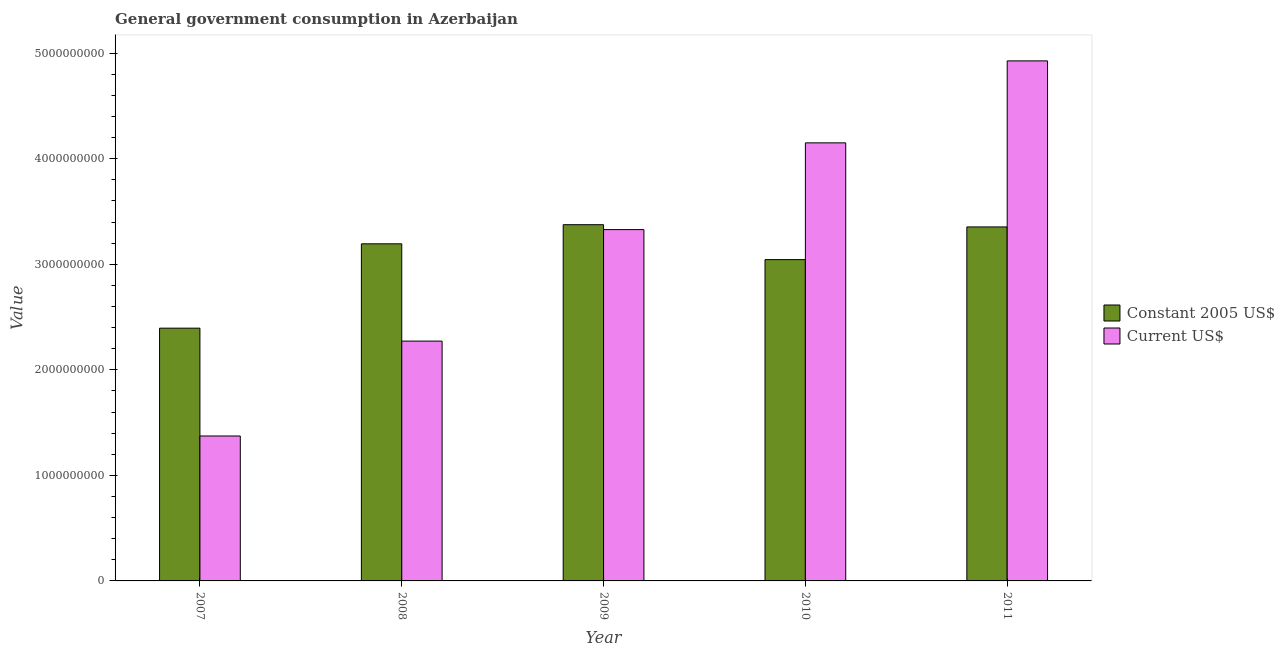How many different coloured bars are there?
Offer a very short reply. 2. Are the number of bars per tick equal to the number of legend labels?
Give a very brief answer. Yes. How many bars are there on the 1st tick from the right?
Offer a very short reply. 2. What is the label of the 1st group of bars from the left?
Your answer should be very brief. 2007. What is the value consumed in constant 2005 us$ in 2011?
Give a very brief answer. 3.35e+09. Across all years, what is the maximum value consumed in current us$?
Offer a very short reply. 4.93e+09. Across all years, what is the minimum value consumed in constant 2005 us$?
Offer a terse response. 2.39e+09. What is the total value consumed in constant 2005 us$ in the graph?
Provide a short and direct response. 1.54e+1. What is the difference between the value consumed in constant 2005 us$ in 2008 and that in 2009?
Your answer should be very brief. -1.81e+08. What is the difference between the value consumed in current us$ in 2008 and the value consumed in constant 2005 us$ in 2010?
Your answer should be compact. -1.88e+09. What is the average value consumed in current us$ per year?
Offer a very short reply. 3.21e+09. What is the ratio of the value consumed in current us$ in 2010 to that in 2011?
Offer a terse response. 0.84. Is the difference between the value consumed in constant 2005 us$ in 2010 and 2011 greater than the difference between the value consumed in current us$ in 2010 and 2011?
Provide a succinct answer. No. What is the difference between the highest and the second highest value consumed in constant 2005 us$?
Your answer should be very brief. 2.11e+07. What is the difference between the highest and the lowest value consumed in current us$?
Ensure brevity in your answer.  3.55e+09. What does the 2nd bar from the left in 2011 represents?
Your answer should be compact. Current US$. What does the 1st bar from the right in 2009 represents?
Offer a terse response. Current US$. How many years are there in the graph?
Your answer should be very brief. 5. What is the difference between two consecutive major ticks on the Y-axis?
Give a very brief answer. 1.00e+09. Does the graph contain any zero values?
Keep it short and to the point. No. Where does the legend appear in the graph?
Provide a succinct answer. Center right. What is the title of the graph?
Make the answer very short. General government consumption in Azerbaijan. What is the label or title of the X-axis?
Give a very brief answer. Year. What is the label or title of the Y-axis?
Make the answer very short. Value. What is the Value in Constant 2005 US$ in 2007?
Keep it short and to the point. 2.39e+09. What is the Value in Current US$ in 2007?
Offer a very short reply. 1.37e+09. What is the Value in Constant 2005 US$ in 2008?
Offer a very short reply. 3.19e+09. What is the Value in Current US$ in 2008?
Your answer should be compact. 2.27e+09. What is the Value in Constant 2005 US$ in 2009?
Your answer should be compact. 3.37e+09. What is the Value of Current US$ in 2009?
Your response must be concise. 3.33e+09. What is the Value in Constant 2005 US$ in 2010?
Offer a terse response. 3.04e+09. What is the Value in Current US$ in 2010?
Provide a short and direct response. 4.15e+09. What is the Value of Constant 2005 US$ in 2011?
Your answer should be compact. 3.35e+09. What is the Value of Current US$ in 2011?
Ensure brevity in your answer.  4.93e+09. Across all years, what is the maximum Value in Constant 2005 US$?
Give a very brief answer. 3.37e+09. Across all years, what is the maximum Value of Current US$?
Ensure brevity in your answer.  4.93e+09. Across all years, what is the minimum Value of Constant 2005 US$?
Your answer should be very brief. 2.39e+09. Across all years, what is the minimum Value in Current US$?
Ensure brevity in your answer.  1.37e+09. What is the total Value of Constant 2005 US$ in the graph?
Keep it short and to the point. 1.54e+1. What is the total Value of Current US$ in the graph?
Provide a short and direct response. 1.61e+1. What is the difference between the Value of Constant 2005 US$ in 2007 and that in 2008?
Offer a terse response. -7.99e+08. What is the difference between the Value of Current US$ in 2007 and that in 2008?
Provide a short and direct response. -8.99e+08. What is the difference between the Value in Constant 2005 US$ in 2007 and that in 2009?
Your answer should be compact. -9.80e+08. What is the difference between the Value in Current US$ in 2007 and that in 2009?
Offer a terse response. -1.96e+09. What is the difference between the Value in Constant 2005 US$ in 2007 and that in 2010?
Provide a short and direct response. -6.49e+08. What is the difference between the Value of Current US$ in 2007 and that in 2010?
Your answer should be compact. -2.78e+09. What is the difference between the Value in Constant 2005 US$ in 2007 and that in 2011?
Provide a short and direct response. -9.59e+08. What is the difference between the Value in Current US$ in 2007 and that in 2011?
Offer a very short reply. -3.55e+09. What is the difference between the Value of Constant 2005 US$ in 2008 and that in 2009?
Make the answer very short. -1.81e+08. What is the difference between the Value of Current US$ in 2008 and that in 2009?
Your answer should be very brief. -1.06e+09. What is the difference between the Value of Constant 2005 US$ in 2008 and that in 2010?
Provide a short and direct response. 1.50e+08. What is the difference between the Value in Current US$ in 2008 and that in 2010?
Keep it short and to the point. -1.88e+09. What is the difference between the Value of Constant 2005 US$ in 2008 and that in 2011?
Make the answer very short. -1.60e+08. What is the difference between the Value of Current US$ in 2008 and that in 2011?
Provide a short and direct response. -2.65e+09. What is the difference between the Value of Constant 2005 US$ in 2009 and that in 2010?
Offer a terse response. 3.31e+08. What is the difference between the Value in Current US$ in 2009 and that in 2010?
Offer a terse response. -8.22e+08. What is the difference between the Value of Constant 2005 US$ in 2009 and that in 2011?
Provide a succinct answer. 2.11e+07. What is the difference between the Value in Current US$ in 2009 and that in 2011?
Give a very brief answer. -1.60e+09. What is the difference between the Value in Constant 2005 US$ in 2010 and that in 2011?
Provide a succinct answer. -3.10e+08. What is the difference between the Value in Current US$ in 2010 and that in 2011?
Give a very brief answer. -7.77e+08. What is the difference between the Value of Constant 2005 US$ in 2007 and the Value of Current US$ in 2008?
Offer a terse response. 1.23e+08. What is the difference between the Value in Constant 2005 US$ in 2007 and the Value in Current US$ in 2009?
Provide a short and direct response. -9.34e+08. What is the difference between the Value in Constant 2005 US$ in 2007 and the Value in Current US$ in 2010?
Provide a short and direct response. -1.76e+09. What is the difference between the Value of Constant 2005 US$ in 2007 and the Value of Current US$ in 2011?
Provide a short and direct response. -2.53e+09. What is the difference between the Value in Constant 2005 US$ in 2008 and the Value in Current US$ in 2009?
Your answer should be very brief. -1.35e+08. What is the difference between the Value of Constant 2005 US$ in 2008 and the Value of Current US$ in 2010?
Offer a very short reply. -9.56e+08. What is the difference between the Value in Constant 2005 US$ in 2008 and the Value in Current US$ in 2011?
Ensure brevity in your answer.  -1.73e+09. What is the difference between the Value of Constant 2005 US$ in 2009 and the Value of Current US$ in 2010?
Provide a short and direct response. -7.75e+08. What is the difference between the Value of Constant 2005 US$ in 2009 and the Value of Current US$ in 2011?
Offer a terse response. -1.55e+09. What is the difference between the Value of Constant 2005 US$ in 2010 and the Value of Current US$ in 2011?
Make the answer very short. -1.88e+09. What is the average Value in Constant 2005 US$ per year?
Ensure brevity in your answer.  3.07e+09. What is the average Value in Current US$ per year?
Keep it short and to the point. 3.21e+09. In the year 2007, what is the difference between the Value of Constant 2005 US$ and Value of Current US$?
Offer a terse response. 1.02e+09. In the year 2008, what is the difference between the Value in Constant 2005 US$ and Value in Current US$?
Offer a very short reply. 9.22e+08. In the year 2009, what is the difference between the Value in Constant 2005 US$ and Value in Current US$?
Your answer should be compact. 4.64e+07. In the year 2010, what is the difference between the Value in Constant 2005 US$ and Value in Current US$?
Ensure brevity in your answer.  -1.11e+09. In the year 2011, what is the difference between the Value of Constant 2005 US$ and Value of Current US$?
Offer a very short reply. -1.57e+09. What is the ratio of the Value of Constant 2005 US$ in 2007 to that in 2008?
Provide a succinct answer. 0.75. What is the ratio of the Value in Current US$ in 2007 to that in 2008?
Keep it short and to the point. 0.6. What is the ratio of the Value in Constant 2005 US$ in 2007 to that in 2009?
Your answer should be very brief. 0.71. What is the ratio of the Value in Current US$ in 2007 to that in 2009?
Provide a succinct answer. 0.41. What is the ratio of the Value in Constant 2005 US$ in 2007 to that in 2010?
Provide a short and direct response. 0.79. What is the ratio of the Value of Current US$ in 2007 to that in 2010?
Give a very brief answer. 0.33. What is the ratio of the Value in Constant 2005 US$ in 2007 to that in 2011?
Your answer should be very brief. 0.71. What is the ratio of the Value of Current US$ in 2007 to that in 2011?
Your response must be concise. 0.28. What is the ratio of the Value of Constant 2005 US$ in 2008 to that in 2009?
Ensure brevity in your answer.  0.95. What is the ratio of the Value of Current US$ in 2008 to that in 2009?
Your response must be concise. 0.68. What is the ratio of the Value in Constant 2005 US$ in 2008 to that in 2010?
Make the answer very short. 1.05. What is the ratio of the Value of Current US$ in 2008 to that in 2010?
Provide a succinct answer. 0.55. What is the ratio of the Value in Constant 2005 US$ in 2008 to that in 2011?
Make the answer very short. 0.95. What is the ratio of the Value of Current US$ in 2008 to that in 2011?
Your response must be concise. 0.46. What is the ratio of the Value of Constant 2005 US$ in 2009 to that in 2010?
Provide a short and direct response. 1.11. What is the ratio of the Value of Current US$ in 2009 to that in 2010?
Your response must be concise. 0.8. What is the ratio of the Value in Constant 2005 US$ in 2009 to that in 2011?
Ensure brevity in your answer.  1.01. What is the ratio of the Value in Current US$ in 2009 to that in 2011?
Give a very brief answer. 0.68. What is the ratio of the Value of Constant 2005 US$ in 2010 to that in 2011?
Give a very brief answer. 0.91. What is the ratio of the Value in Current US$ in 2010 to that in 2011?
Offer a very short reply. 0.84. What is the difference between the highest and the second highest Value in Constant 2005 US$?
Your answer should be compact. 2.11e+07. What is the difference between the highest and the second highest Value of Current US$?
Keep it short and to the point. 7.77e+08. What is the difference between the highest and the lowest Value in Constant 2005 US$?
Your answer should be compact. 9.80e+08. What is the difference between the highest and the lowest Value in Current US$?
Give a very brief answer. 3.55e+09. 